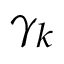<formula> <loc_0><loc_0><loc_500><loc_500>{ { \gamma } _ { k } }</formula> 